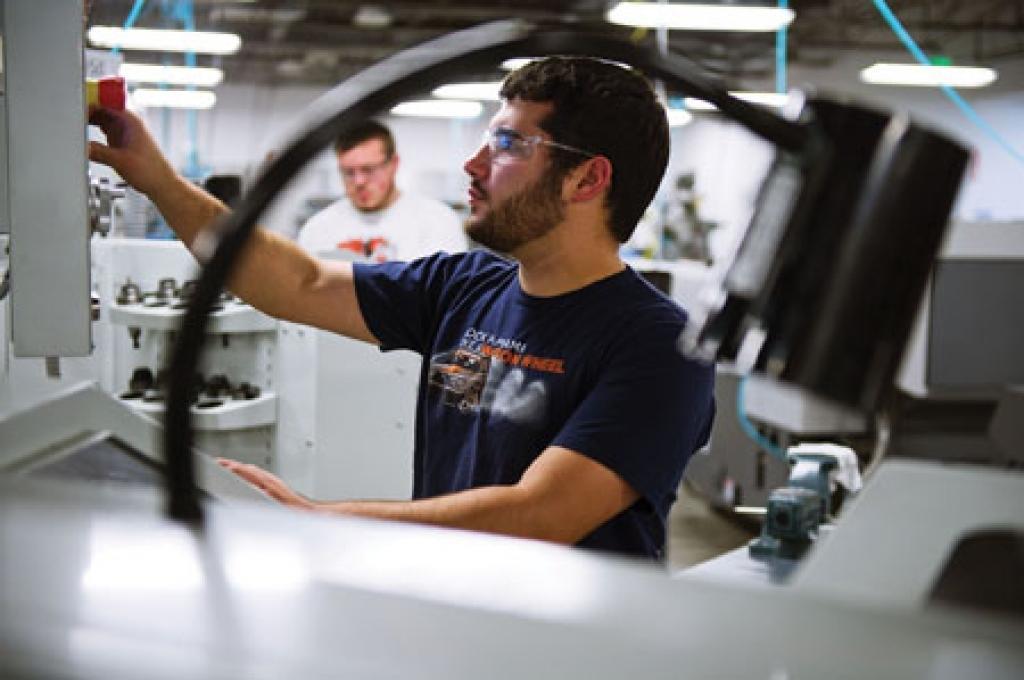In one or two sentences, can you explain what this image depicts? In this picture I can see a man operating a machine with his hand and he wore spectacles and I can see another man standing on the side and I can see few lights. 